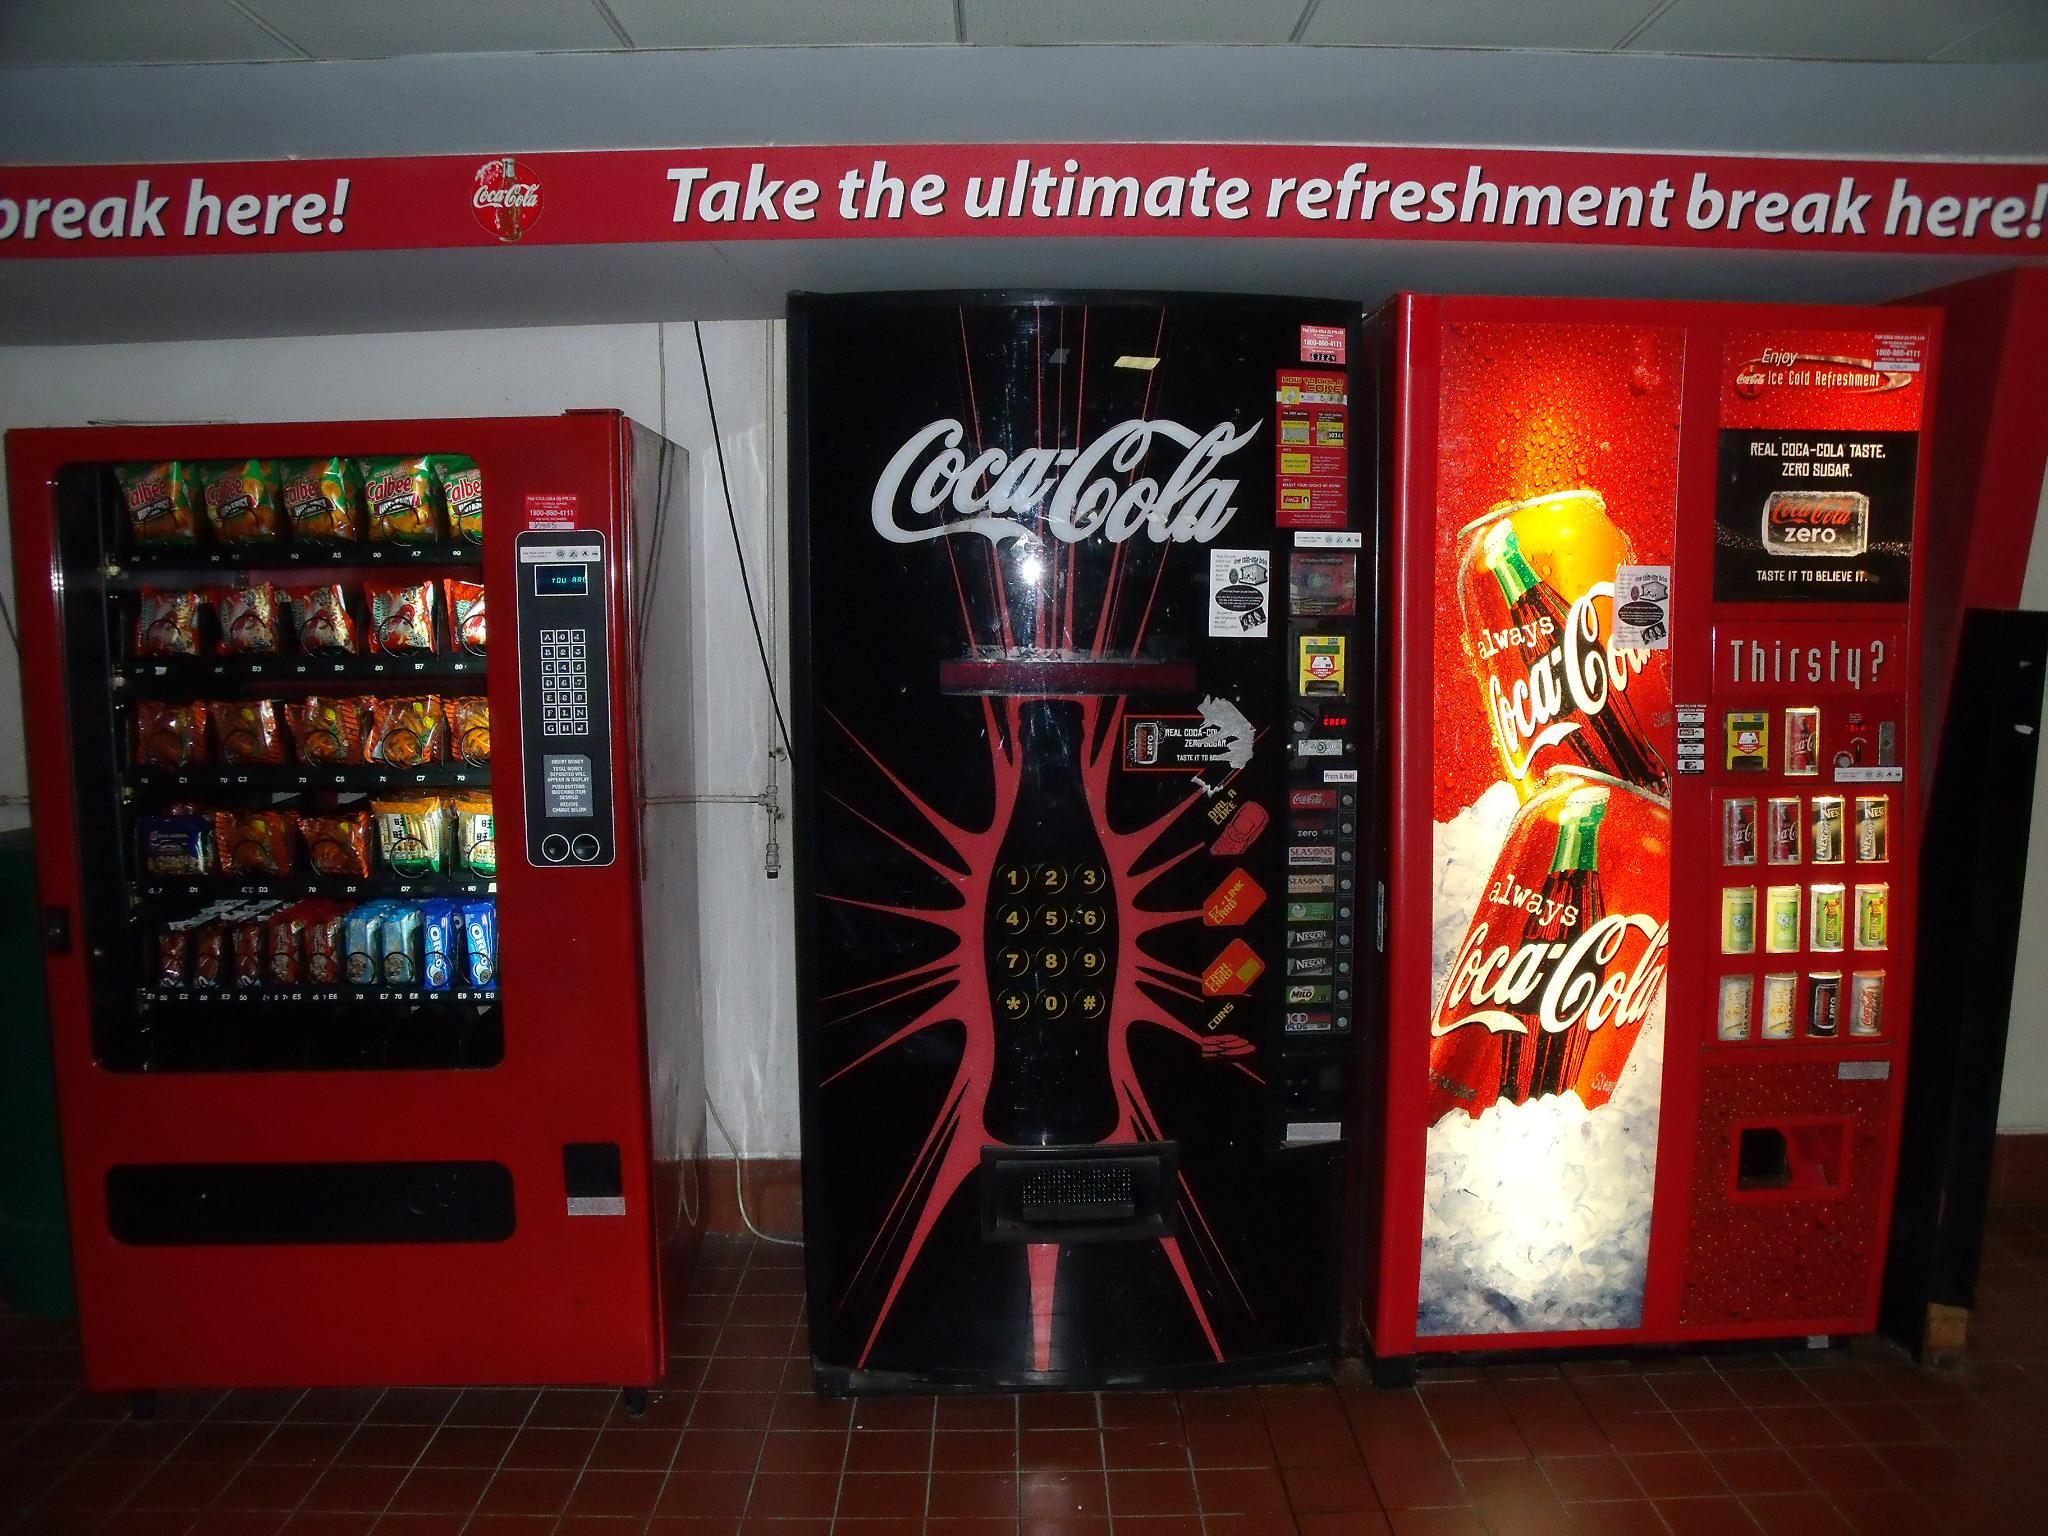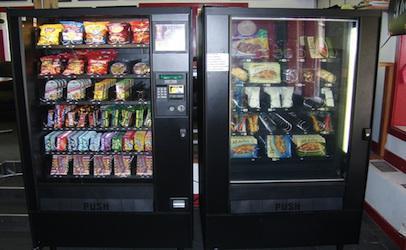The first image is the image on the left, the second image is the image on the right. Given the left and right images, does the statement "At least one image shows only beverage vending options." hold true? Answer yes or no. No. 